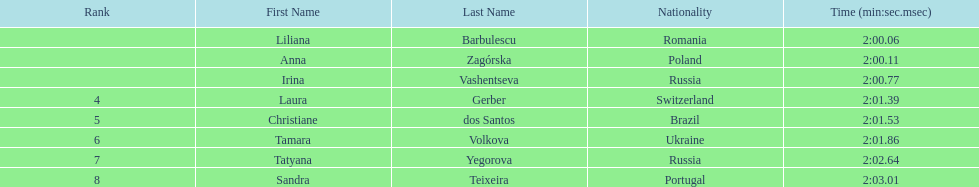The last runner crossed the finish line in 2:03.01. what was the previous time for the 7th runner? 2:02.64. 